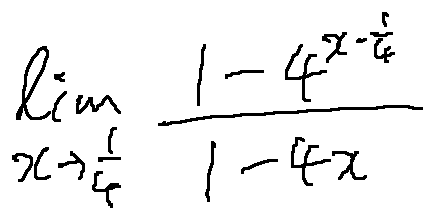<formula> <loc_0><loc_0><loc_500><loc_500>\lim \lim i t s _ { x \rightarrow \frac { 1 } { 4 } } \frac { 1 - 4 ^ { x - \frac { 1 } { 4 } } } { 1 - 4 x }</formula> 